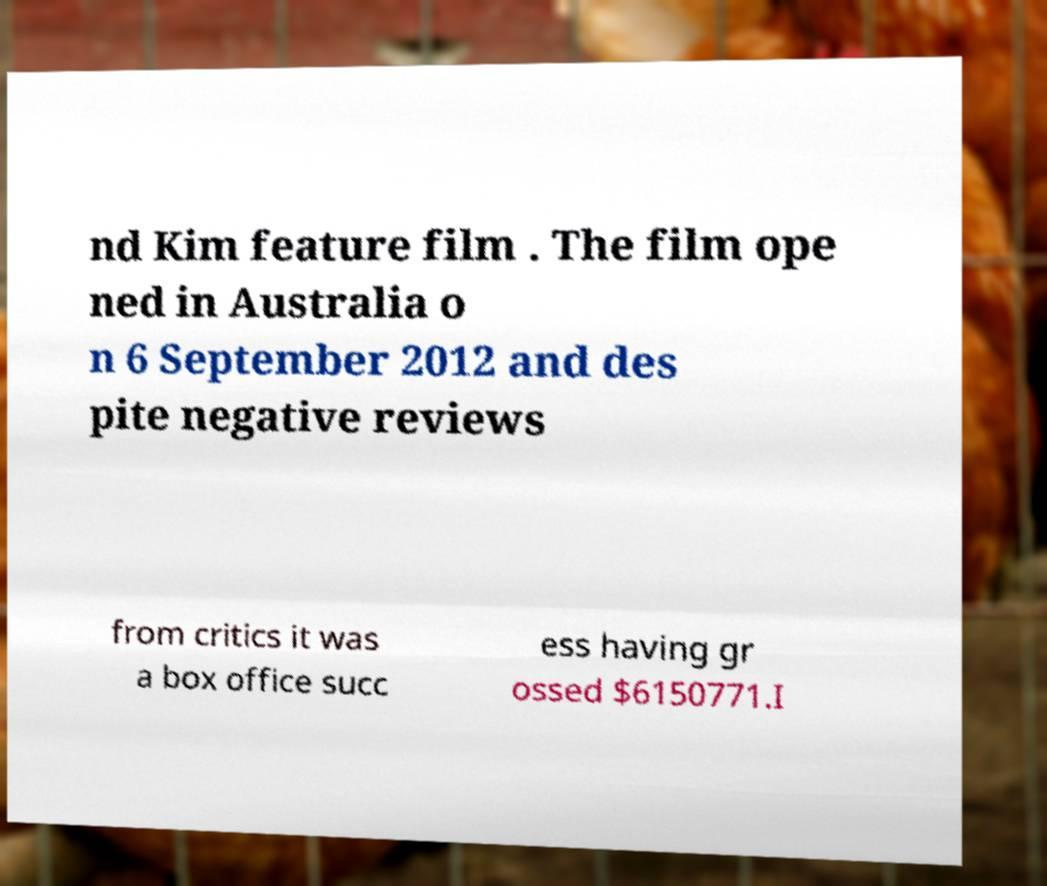I need the written content from this picture converted into text. Can you do that? nd Kim feature film . The film ope ned in Australia o n 6 September 2012 and des pite negative reviews from critics it was a box office succ ess having gr ossed $6150771.I 